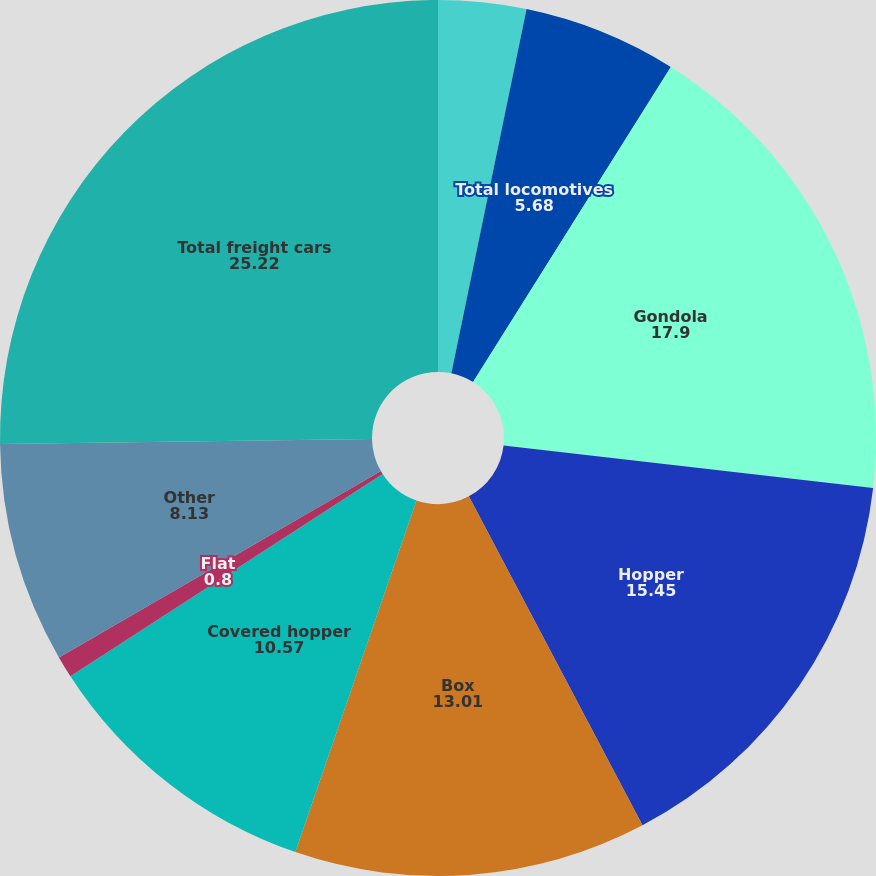Convert chart. <chart><loc_0><loc_0><loc_500><loc_500><pie_chart><fcel>Multiple purpose<fcel>Total locomotives<fcel>Gondola<fcel>Hopper<fcel>Box<fcel>Covered hopper<fcel>Flat<fcel>Other<fcel>Total freight cars<nl><fcel>3.24%<fcel>5.68%<fcel>17.9%<fcel>15.45%<fcel>13.01%<fcel>10.57%<fcel>0.8%<fcel>8.13%<fcel>25.22%<nl></chart> 